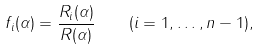<formula> <loc_0><loc_0><loc_500><loc_500>f _ { i } ( \alpha ) = \frac { R _ { i } ( \alpha ) } { R ( \alpha ) } \quad ( i = 1 , \dots , n - 1 ) ,</formula> 